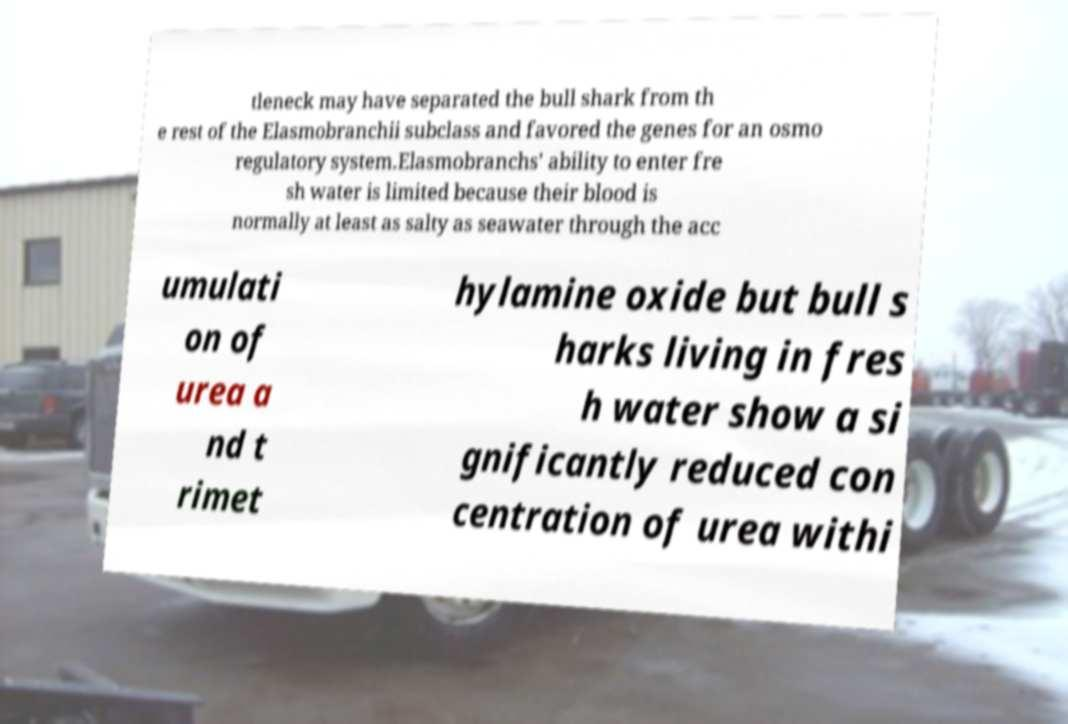Could you extract and type out the text from this image? tleneck may have separated the bull shark from th e rest of the Elasmobranchii subclass and favored the genes for an osmo regulatory system.Elasmobranchs' ability to enter fre sh water is limited because their blood is normally at least as salty as seawater through the acc umulati on of urea a nd t rimet hylamine oxide but bull s harks living in fres h water show a si gnificantly reduced con centration of urea withi 